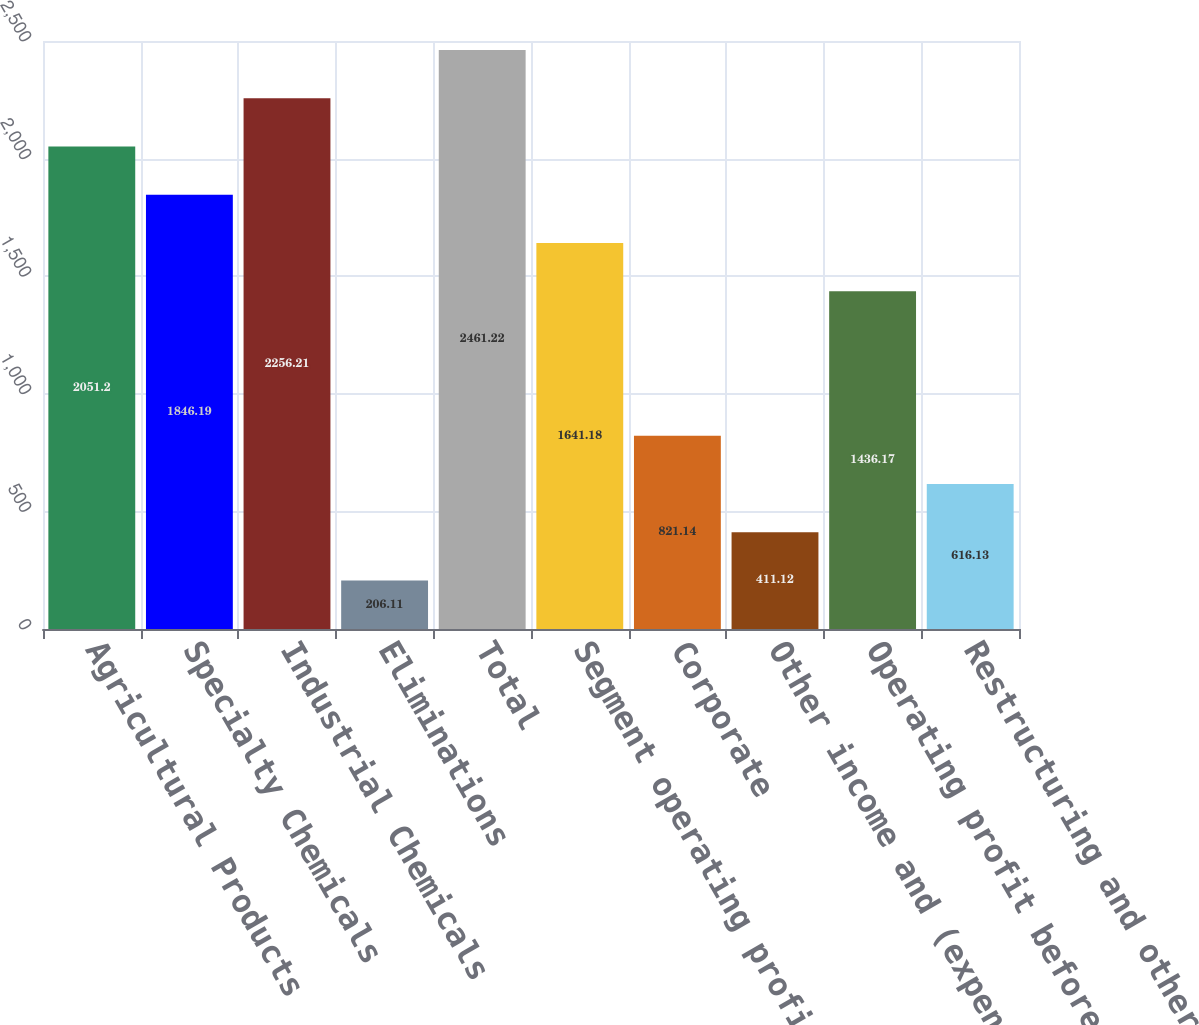<chart> <loc_0><loc_0><loc_500><loc_500><bar_chart><fcel>Agricultural Products<fcel>Specialty Chemicals<fcel>Industrial Chemicals<fcel>Eliminations<fcel>Total<fcel>Segment operating profit (1)<fcel>Corporate<fcel>Other income and (expense) net<fcel>Operating profit before<fcel>Restructuring and other<nl><fcel>2051.2<fcel>1846.19<fcel>2256.21<fcel>206.11<fcel>2461.22<fcel>1641.18<fcel>821.14<fcel>411.12<fcel>1436.17<fcel>616.13<nl></chart> 